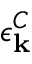Convert formula to latex. <formula><loc_0><loc_0><loc_500><loc_500>\epsilon _ { k } ^ { C }</formula> 